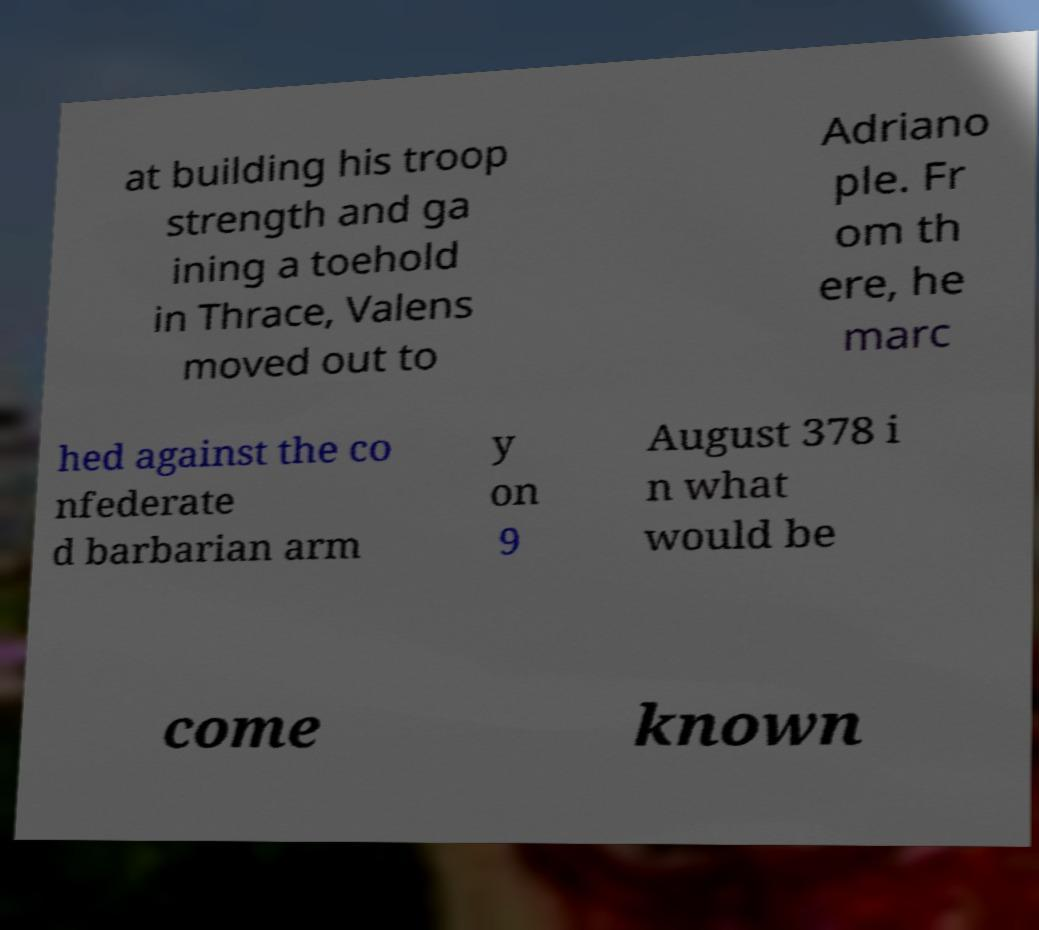Please identify and transcribe the text found in this image. at building his troop strength and ga ining a toehold in Thrace, Valens moved out to Adriano ple. Fr om th ere, he marc hed against the co nfederate d barbarian arm y on 9 August 378 i n what would be come known 